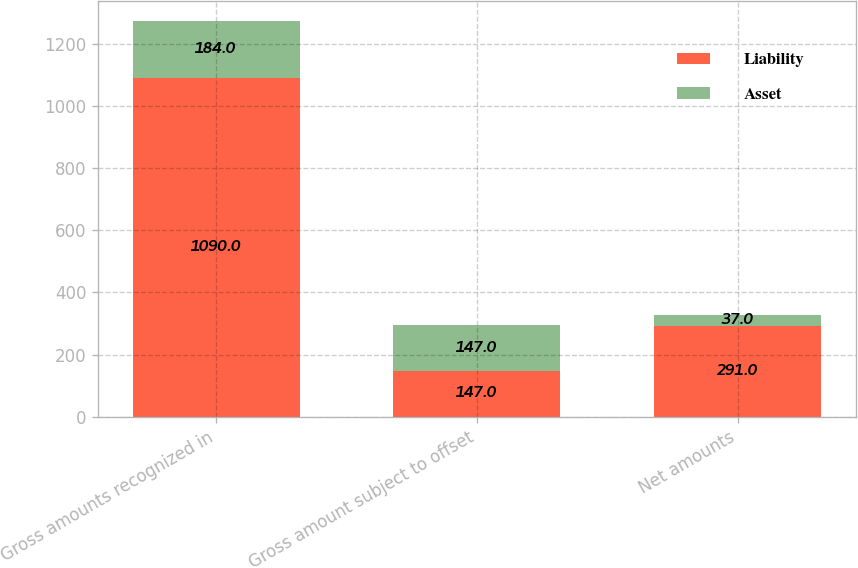<chart> <loc_0><loc_0><loc_500><loc_500><stacked_bar_chart><ecel><fcel>Gross amounts recognized in<fcel>Gross amount subject to offset<fcel>Net amounts<nl><fcel>Liability<fcel>1090<fcel>147<fcel>291<nl><fcel>Asset<fcel>184<fcel>147<fcel>37<nl></chart> 